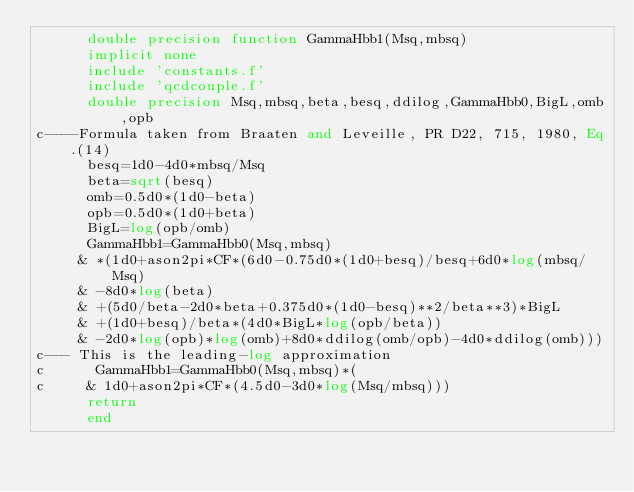Convert code to text. <code><loc_0><loc_0><loc_500><loc_500><_FORTRAN_>      double precision function GammaHbb1(Msq,mbsq)
      implicit none
      include 'constants.f'
      include 'qcdcouple.f'
      double precision Msq,mbsq,beta,besq,ddilog,GammaHbb0,BigL,omb,opb
c----Formula taken from Braaten and Leveille, PR D22, 715, 1980, Eq.(14)
      besq=1d0-4d0*mbsq/Msq
      beta=sqrt(besq)
      omb=0.5d0*(1d0-beta)
      opb=0.5d0*(1d0+beta)
      BigL=log(opb/omb)
      GammaHbb1=GammaHbb0(Msq,mbsq)
     & *(1d0+ason2pi*CF*(6d0-0.75d0*(1d0+besq)/besq+6d0*log(mbsq/Msq)
     & -8d0*log(beta)
     & +(5d0/beta-2d0*beta+0.375d0*(1d0-besq)**2/beta**3)*BigL
     & +(1d0+besq)/beta*(4d0*BigL*log(opb/beta))
     & -2d0*log(opb)*log(omb)+8d0*ddilog(omb/opb)-4d0*ddilog(omb)))
c--- This is the leading-log approximation
c      GammaHbb1=GammaHbb0(Msq,mbsq)*(
c     & 1d0+ason2pi*CF*(4.5d0-3d0*log(Msq/mbsq)))
      return
      end
</code> 